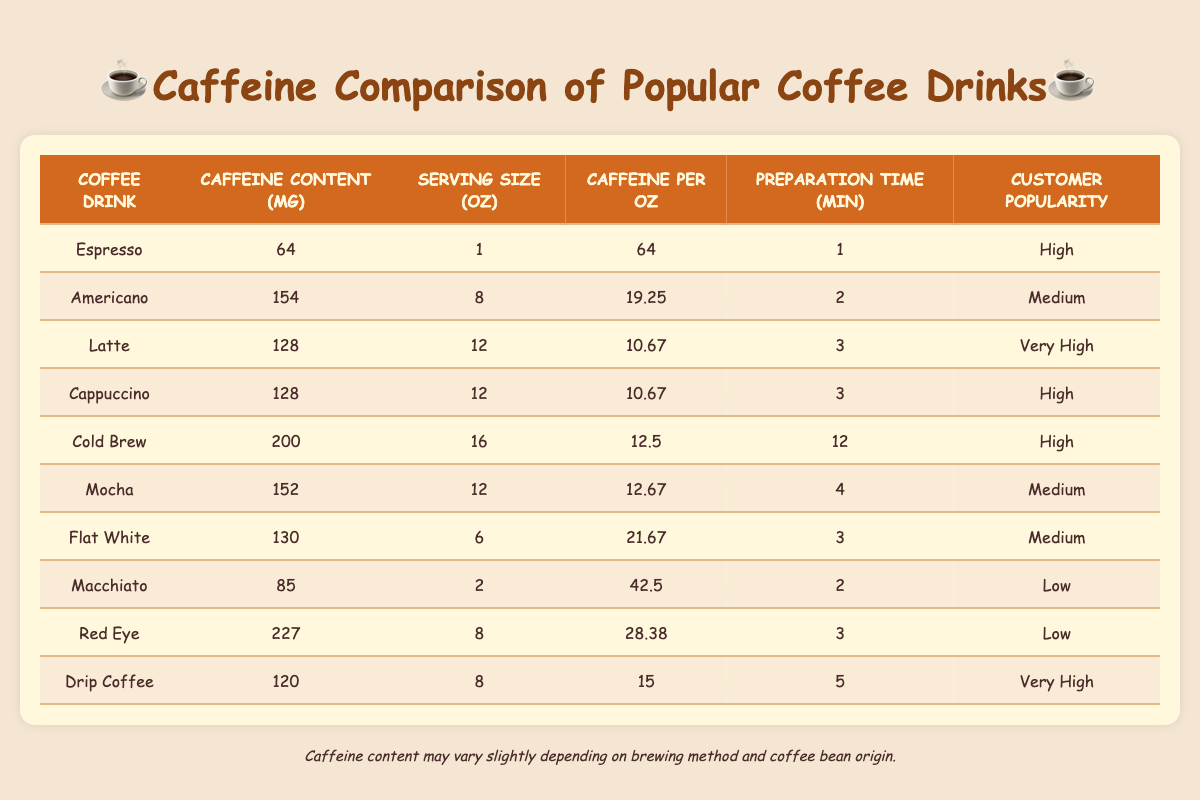What coffee drink has the highest caffeine content? The caffeine content for each drink is listed in the table. By comparing the values, I see that the Red Eye has the highest caffeine content at 227 mg.
Answer: Red Eye What is the caffeine content of a Flat White? From the table, I can find the Flat White row, which shows the caffeine content listed as 130 mg.
Answer: 130 mg Which coffee drinks have a preparation time of 3 minutes? I check the preparation time column for each drink. The Latte, Cappuccino, Flat White, and Red Eye all have a preparation time of 3 minutes.
Answer: Latte, Cappuccino, Flat White, Red Eye What is the average caffeine content of all the drinks? To find the average, I sum all the caffeine contents: (64 + 154 + 128 + 128 + 200 + 152 + 130 + 85 + 227 + 120) = 1358. There are 10 drinks, so the average is 1358 / 10 = 135.8. I’ll round it to 136 mg for simplicity.
Answer: 136 mg True or False: A Latte has more caffeine content than an Americano. I compare the caffeine content of both drinks from the table. The Latte has 128 mg while the Americano has 154 mg. Since 128 is less than 154, the statement is false.
Answer: False What is the caffeine per ounce of the Cold Brew? I look at the Cold Brew row in the table, where it shows that the caffeine per ounce is 12.5 mg.
Answer: 12.5 mg Which drink has the lowest customer popularity rating? I review the customer popularity column and see that the Macchiato and Red Eye are both rated as Low, making them the least popular drinks.
Answer: Macchiato, Red Eye What drink contains more caffeine, a Drip Coffee or a Macchiato? Checking the caffeine content in the table, Drip Coffee has 120 mg whereas Macchiato has 85 mg. Since 120 mg is greater than 85 mg, Drip Coffee contains more caffeine.
Answer: Drip Coffee How long does it take to prepare a Cold Brew compared to a Latte? By referring to the preparation time column, the Cold Brew says 12 minutes while the Latte is 3 minutes. The Cold Brew takes significantly longer to prepare than the Latte.
Answer: Cold Brew (12 min), Latte (3 min) 